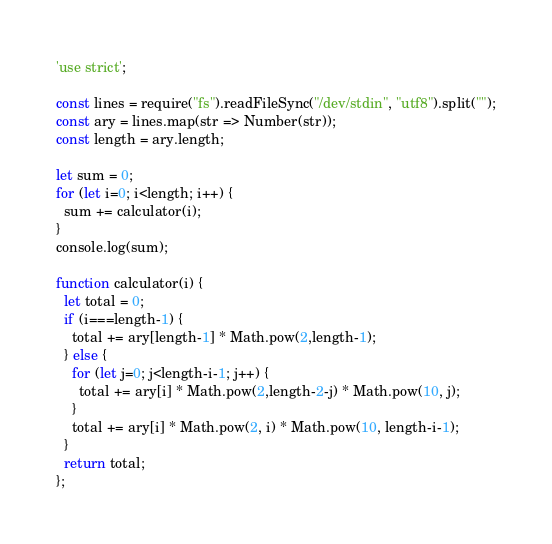<code> <loc_0><loc_0><loc_500><loc_500><_JavaScript_>'use strict';

const lines = require("fs").readFileSync("/dev/stdin", "utf8").split("");
const ary = lines.map(str => Number(str));
const length = ary.length;

let sum = 0;
for (let i=0; i<length; i++) {
  sum += calculator(i);
}
console.log(sum);

function calculator(i) {
  let total = 0;
  if (i===length-1) {
    total += ary[length-1] * Math.pow(2,length-1);
  } else {
    for (let j=0; j<length-i-1; j++) {
      total += ary[i] * Math.pow(2,length-2-j) * Math.pow(10, j);
    }
    total += ary[i] * Math.pow(2, i) * Math.pow(10, length-i-1);
  }
  return total;
};</code> 